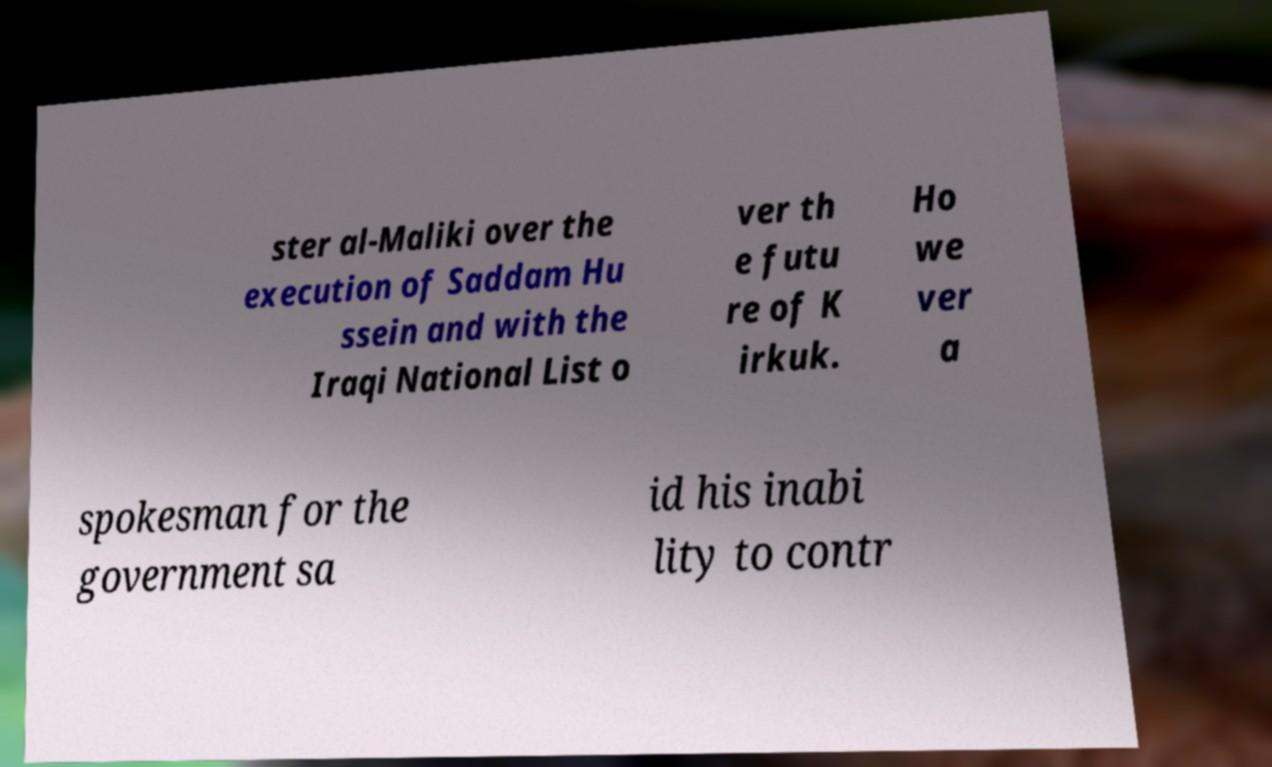What messages or text are displayed in this image? I need them in a readable, typed format. ster al-Maliki over the execution of Saddam Hu ssein and with the Iraqi National List o ver th e futu re of K irkuk. Ho we ver a spokesman for the government sa id his inabi lity to contr 